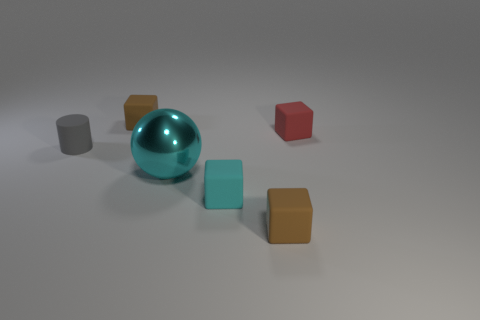What number of rubber objects are right of the tiny cyan matte cube and to the left of the tiny red matte object?
Provide a succinct answer. 1. What number of brown objects are metallic things or small blocks?
Your answer should be very brief. 2. Does the tiny cube on the left side of the large metal sphere have the same color as the tiny object that is in front of the tiny cyan object?
Make the answer very short. Yes. What color is the rubber cube that is on the right side of the tiny brown cube in front of the brown rubber thing that is behind the small cyan thing?
Your answer should be compact. Red. Is there a red block to the right of the brown object to the left of the cyan metal ball?
Your answer should be very brief. Yes. There is a brown matte thing that is in front of the small gray rubber cylinder; is its shape the same as the small red rubber object?
Give a very brief answer. Yes. Is there anything else that has the same shape as the large cyan object?
Provide a succinct answer. No. How many cylinders are either red rubber objects or small things?
Make the answer very short. 1. How many big cyan metal balls are there?
Offer a very short reply. 1. What is the size of the sphere that is in front of the tiny cylinder that is behind the cyan metal ball?
Ensure brevity in your answer.  Large. 